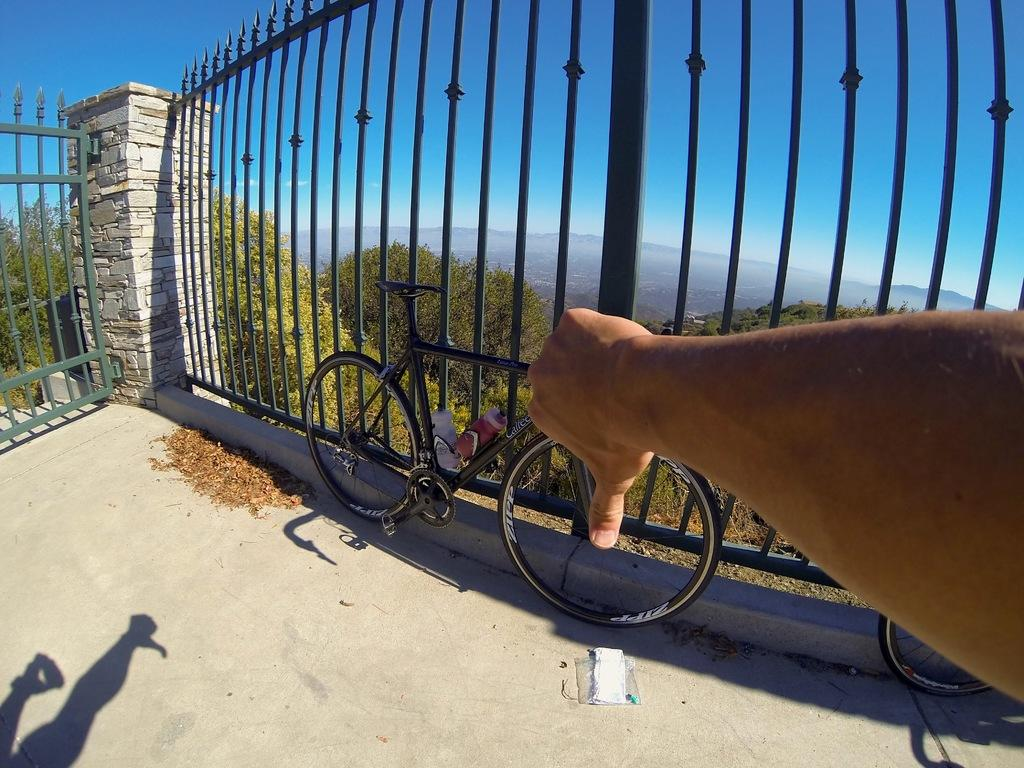What can be seen on the right side of the image? There is a human hand on the right side of the image. What is visible in the background of the image? There is sky, trees, a pillar, a fence, and a cycle visible in the background of the image. What type of furniture is being carried by the porter in the image? There is no porter or furniture present in the image. What tasks might the secretary be performing in the image? There is no secretary present in the image. 